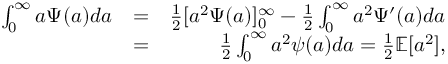Convert formula to latex. <formula><loc_0><loc_0><loc_500><loc_500>\begin{array} { r l r } { \int _ { 0 } ^ { \infty } a \Psi ( a ) d a } & { = } & { \frac { 1 } { 2 } [ a ^ { 2 } \Psi ( a ) ] _ { 0 } ^ { \infty } - \frac { 1 } { 2 } \int _ { 0 } ^ { \infty } a ^ { 2 } \Psi ^ { \prime } ( a ) d a } \\ & { = } & { \frac { 1 } { 2 } \int _ { 0 } ^ { \infty } a ^ { 2 } \psi ( a ) d a = \frac { 1 } { 2 } { \mathbb { E } } [ a ^ { 2 } ] , } \end{array}</formula> 